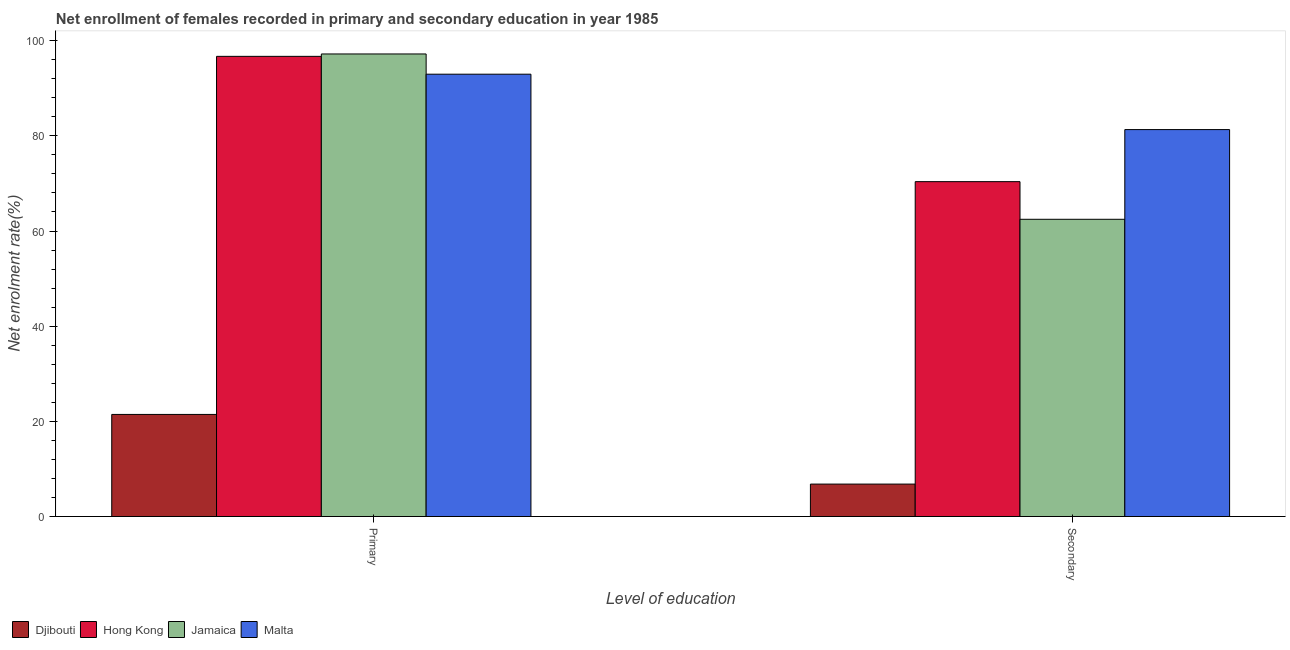How many different coloured bars are there?
Your response must be concise. 4. Are the number of bars per tick equal to the number of legend labels?
Ensure brevity in your answer.  Yes. Are the number of bars on each tick of the X-axis equal?
Provide a short and direct response. Yes. How many bars are there on the 2nd tick from the left?
Provide a succinct answer. 4. How many bars are there on the 1st tick from the right?
Your response must be concise. 4. What is the label of the 2nd group of bars from the left?
Your answer should be very brief. Secondary. What is the enrollment rate in secondary education in Malta?
Provide a short and direct response. 81.31. Across all countries, what is the maximum enrollment rate in primary education?
Your answer should be compact. 97.21. Across all countries, what is the minimum enrollment rate in secondary education?
Offer a very short reply. 6.82. In which country was the enrollment rate in primary education maximum?
Provide a short and direct response. Jamaica. In which country was the enrollment rate in secondary education minimum?
Make the answer very short. Djibouti. What is the total enrollment rate in primary education in the graph?
Your answer should be very brief. 308.32. What is the difference between the enrollment rate in secondary education in Hong Kong and that in Djibouti?
Provide a short and direct response. 63.56. What is the difference between the enrollment rate in primary education in Djibouti and the enrollment rate in secondary education in Hong Kong?
Offer a very short reply. -48.92. What is the average enrollment rate in primary education per country?
Your answer should be compact. 77.08. What is the difference between the enrollment rate in secondary education and enrollment rate in primary education in Djibouti?
Offer a very short reply. -14.64. What is the ratio of the enrollment rate in secondary education in Jamaica to that in Malta?
Make the answer very short. 0.77. Is the enrollment rate in primary education in Hong Kong less than that in Jamaica?
Offer a terse response. Yes. In how many countries, is the enrollment rate in primary education greater than the average enrollment rate in primary education taken over all countries?
Your answer should be compact. 3. What does the 4th bar from the left in Secondary represents?
Make the answer very short. Malta. What does the 2nd bar from the right in Primary represents?
Give a very brief answer. Jamaica. Are all the bars in the graph horizontal?
Your answer should be very brief. No. What is the difference between two consecutive major ticks on the Y-axis?
Ensure brevity in your answer.  20. Does the graph contain any zero values?
Offer a terse response. No. Does the graph contain grids?
Provide a succinct answer. No. Where does the legend appear in the graph?
Your answer should be compact. Bottom left. What is the title of the graph?
Keep it short and to the point. Net enrollment of females recorded in primary and secondary education in year 1985. What is the label or title of the X-axis?
Make the answer very short. Level of education. What is the label or title of the Y-axis?
Offer a very short reply. Net enrolment rate(%). What is the Net enrolment rate(%) of Djibouti in Primary?
Offer a very short reply. 21.46. What is the Net enrolment rate(%) of Hong Kong in Primary?
Provide a short and direct response. 96.7. What is the Net enrolment rate(%) of Jamaica in Primary?
Your response must be concise. 97.21. What is the Net enrolment rate(%) in Malta in Primary?
Provide a succinct answer. 92.95. What is the Net enrolment rate(%) of Djibouti in Secondary?
Offer a terse response. 6.82. What is the Net enrolment rate(%) of Hong Kong in Secondary?
Give a very brief answer. 70.37. What is the Net enrolment rate(%) of Jamaica in Secondary?
Make the answer very short. 62.46. What is the Net enrolment rate(%) of Malta in Secondary?
Your answer should be very brief. 81.31. Across all Level of education, what is the maximum Net enrolment rate(%) of Djibouti?
Provide a succinct answer. 21.46. Across all Level of education, what is the maximum Net enrolment rate(%) in Hong Kong?
Ensure brevity in your answer.  96.7. Across all Level of education, what is the maximum Net enrolment rate(%) in Jamaica?
Make the answer very short. 97.21. Across all Level of education, what is the maximum Net enrolment rate(%) of Malta?
Your answer should be very brief. 92.95. Across all Level of education, what is the minimum Net enrolment rate(%) in Djibouti?
Provide a succinct answer. 6.82. Across all Level of education, what is the minimum Net enrolment rate(%) in Hong Kong?
Provide a succinct answer. 70.37. Across all Level of education, what is the minimum Net enrolment rate(%) of Jamaica?
Give a very brief answer. 62.46. Across all Level of education, what is the minimum Net enrolment rate(%) of Malta?
Make the answer very short. 81.31. What is the total Net enrolment rate(%) in Djibouti in the graph?
Give a very brief answer. 28.27. What is the total Net enrolment rate(%) in Hong Kong in the graph?
Your answer should be compact. 167.07. What is the total Net enrolment rate(%) of Jamaica in the graph?
Offer a very short reply. 159.67. What is the total Net enrolment rate(%) in Malta in the graph?
Provide a short and direct response. 174.27. What is the difference between the Net enrolment rate(%) in Djibouti in Primary and that in Secondary?
Make the answer very short. 14.64. What is the difference between the Net enrolment rate(%) of Hong Kong in Primary and that in Secondary?
Your answer should be very brief. 26.33. What is the difference between the Net enrolment rate(%) in Jamaica in Primary and that in Secondary?
Give a very brief answer. 34.75. What is the difference between the Net enrolment rate(%) of Malta in Primary and that in Secondary?
Provide a succinct answer. 11.64. What is the difference between the Net enrolment rate(%) in Djibouti in Primary and the Net enrolment rate(%) in Hong Kong in Secondary?
Provide a short and direct response. -48.92. What is the difference between the Net enrolment rate(%) in Djibouti in Primary and the Net enrolment rate(%) in Jamaica in Secondary?
Make the answer very short. -41.01. What is the difference between the Net enrolment rate(%) of Djibouti in Primary and the Net enrolment rate(%) of Malta in Secondary?
Provide a succinct answer. -59.86. What is the difference between the Net enrolment rate(%) in Hong Kong in Primary and the Net enrolment rate(%) in Jamaica in Secondary?
Keep it short and to the point. 34.24. What is the difference between the Net enrolment rate(%) in Hong Kong in Primary and the Net enrolment rate(%) in Malta in Secondary?
Keep it short and to the point. 15.39. What is the difference between the Net enrolment rate(%) in Jamaica in Primary and the Net enrolment rate(%) in Malta in Secondary?
Provide a short and direct response. 15.89. What is the average Net enrolment rate(%) of Djibouti per Level of education?
Provide a succinct answer. 14.14. What is the average Net enrolment rate(%) of Hong Kong per Level of education?
Your answer should be compact. 83.54. What is the average Net enrolment rate(%) in Jamaica per Level of education?
Offer a very short reply. 79.83. What is the average Net enrolment rate(%) of Malta per Level of education?
Your answer should be compact. 87.13. What is the difference between the Net enrolment rate(%) in Djibouti and Net enrolment rate(%) in Hong Kong in Primary?
Keep it short and to the point. -75.25. What is the difference between the Net enrolment rate(%) in Djibouti and Net enrolment rate(%) in Jamaica in Primary?
Provide a short and direct response. -75.75. What is the difference between the Net enrolment rate(%) of Djibouti and Net enrolment rate(%) of Malta in Primary?
Provide a short and direct response. -71.5. What is the difference between the Net enrolment rate(%) in Hong Kong and Net enrolment rate(%) in Jamaica in Primary?
Make the answer very short. -0.5. What is the difference between the Net enrolment rate(%) in Hong Kong and Net enrolment rate(%) in Malta in Primary?
Your answer should be very brief. 3.75. What is the difference between the Net enrolment rate(%) in Jamaica and Net enrolment rate(%) in Malta in Primary?
Your answer should be compact. 4.25. What is the difference between the Net enrolment rate(%) of Djibouti and Net enrolment rate(%) of Hong Kong in Secondary?
Keep it short and to the point. -63.56. What is the difference between the Net enrolment rate(%) of Djibouti and Net enrolment rate(%) of Jamaica in Secondary?
Provide a succinct answer. -55.64. What is the difference between the Net enrolment rate(%) of Djibouti and Net enrolment rate(%) of Malta in Secondary?
Offer a very short reply. -74.5. What is the difference between the Net enrolment rate(%) in Hong Kong and Net enrolment rate(%) in Jamaica in Secondary?
Offer a very short reply. 7.91. What is the difference between the Net enrolment rate(%) of Hong Kong and Net enrolment rate(%) of Malta in Secondary?
Make the answer very short. -10.94. What is the difference between the Net enrolment rate(%) in Jamaica and Net enrolment rate(%) in Malta in Secondary?
Provide a succinct answer. -18.85. What is the ratio of the Net enrolment rate(%) in Djibouti in Primary to that in Secondary?
Your response must be concise. 3.15. What is the ratio of the Net enrolment rate(%) of Hong Kong in Primary to that in Secondary?
Your answer should be very brief. 1.37. What is the ratio of the Net enrolment rate(%) in Jamaica in Primary to that in Secondary?
Your answer should be very brief. 1.56. What is the ratio of the Net enrolment rate(%) in Malta in Primary to that in Secondary?
Offer a very short reply. 1.14. What is the difference between the highest and the second highest Net enrolment rate(%) in Djibouti?
Offer a very short reply. 14.64. What is the difference between the highest and the second highest Net enrolment rate(%) of Hong Kong?
Offer a terse response. 26.33. What is the difference between the highest and the second highest Net enrolment rate(%) of Jamaica?
Provide a short and direct response. 34.75. What is the difference between the highest and the second highest Net enrolment rate(%) in Malta?
Keep it short and to the point. 11.64. What is the difference between the highest and the lowest Net enrolment rate(%) in Djibouti?
Ensure brevity in your answer.  14.64. What is the difference between the highest and the lowest Net enrolment rate(%) of Hong Kong?
Provide a short and direct response. 26.33. What is the difference between the highest and the lowest Net enrolment rate(%) of Jamaica?
Your answer should be compact. 34.75. What is the difference between the highest and the lowest Net enrolment rate(%) of Malta?
Keep it short and to the point. 11.64. 